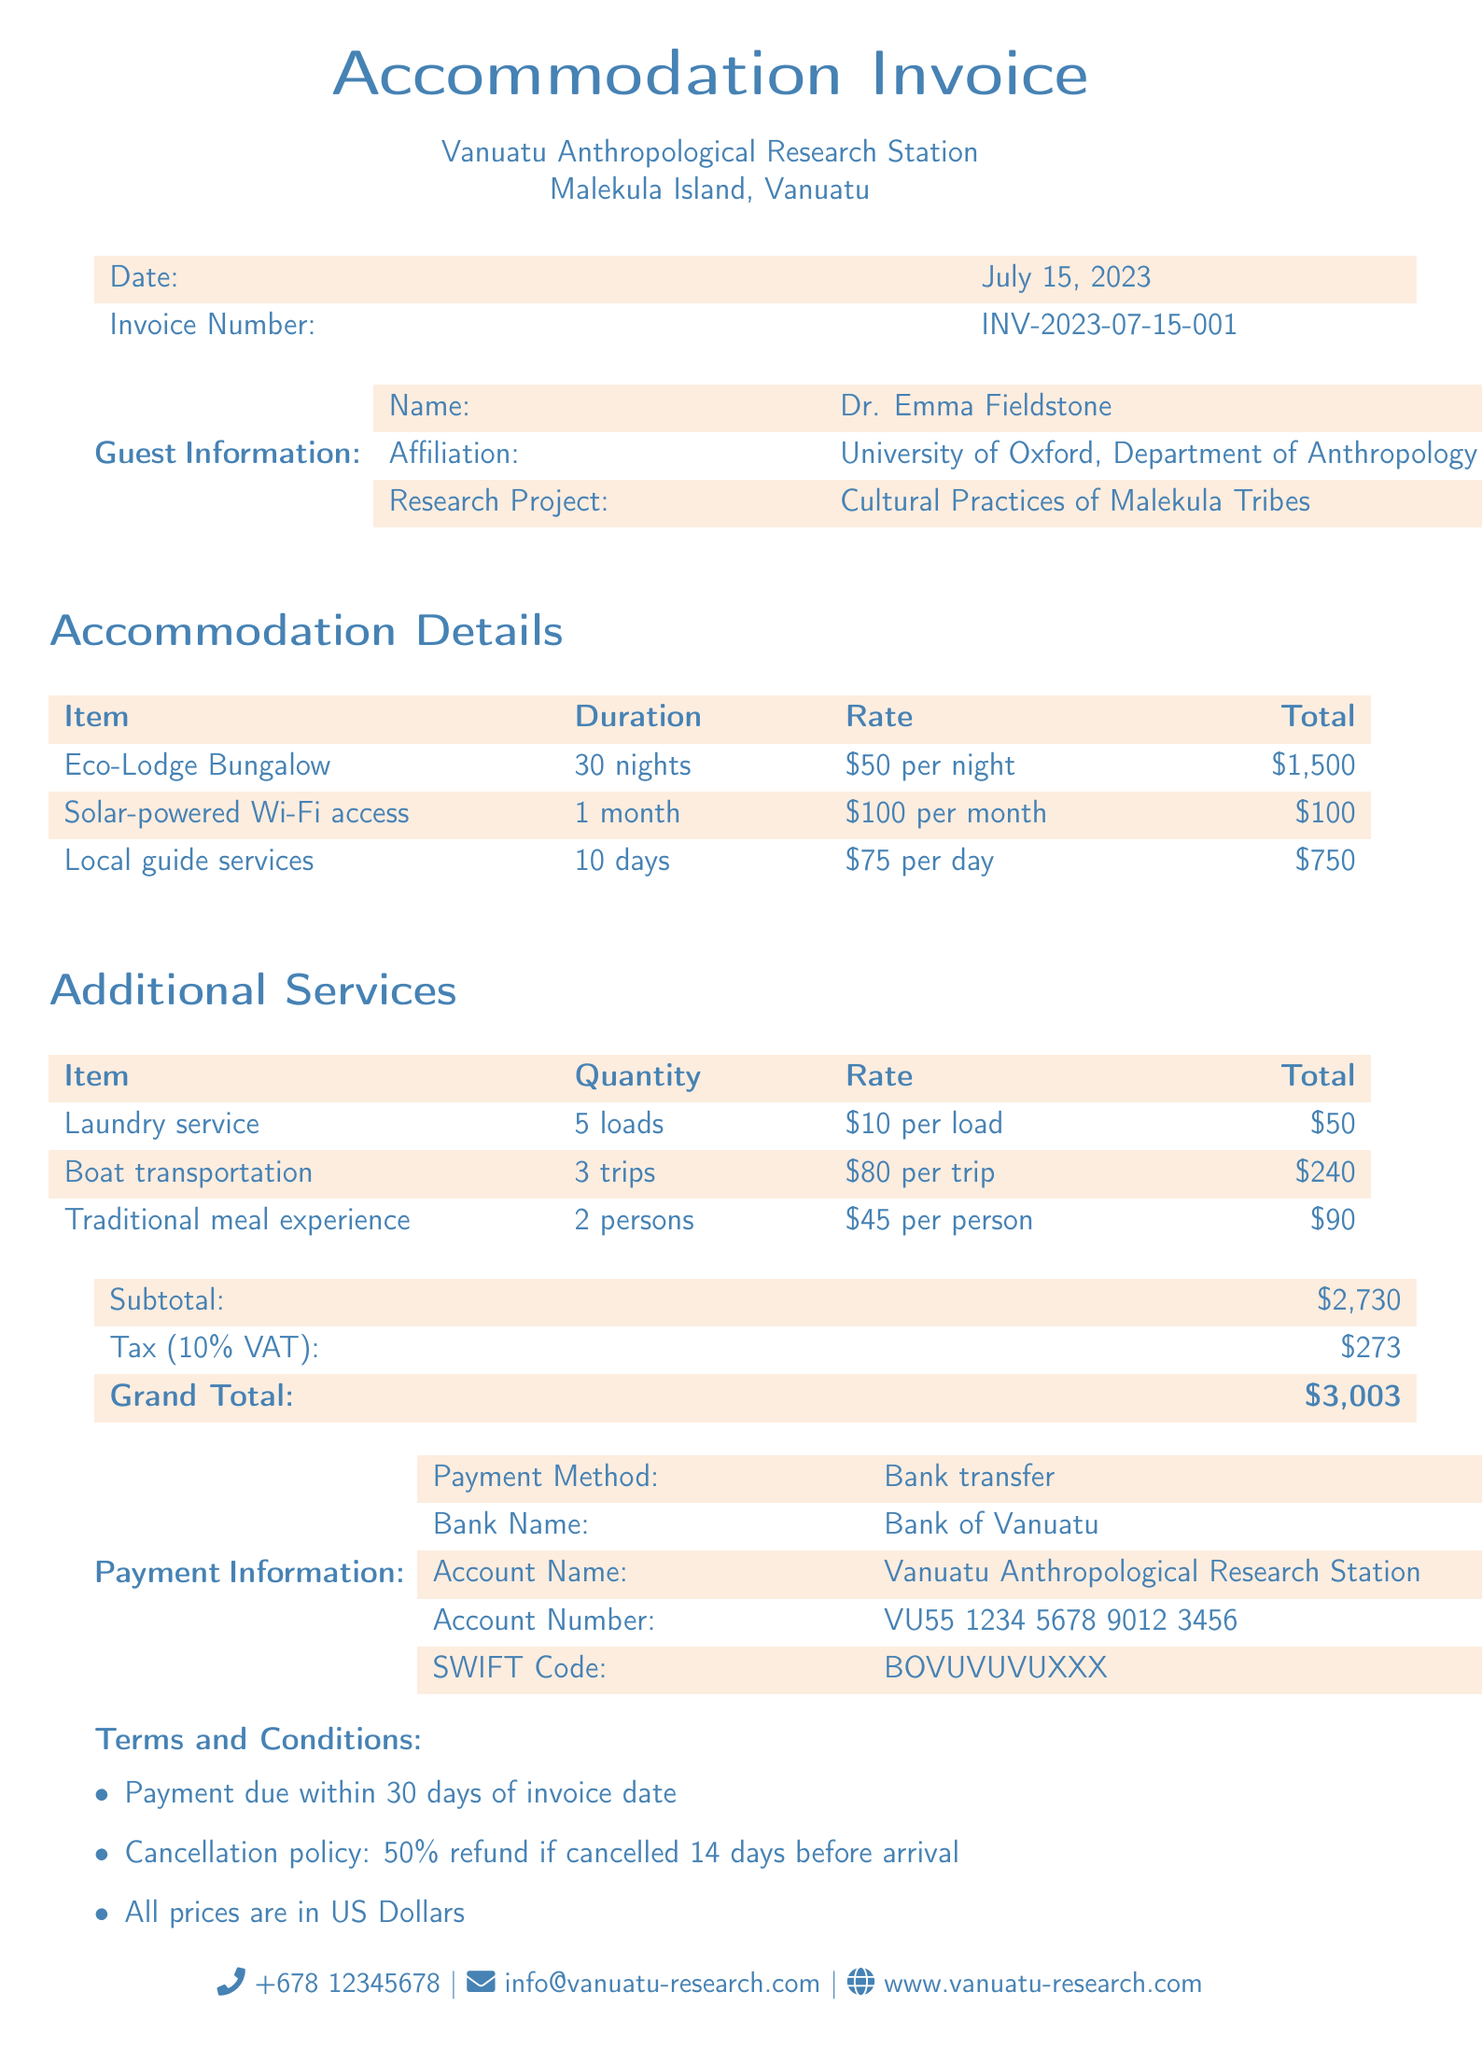what is the invoice number? The invoice number is a unique identifier for the bill, listed in the document.
Answer: INV-2023-07-15-001 who is the guest? The guest's name is provided in the document under guest information.
Answer: Dr. Emma Fieldstone what is the duration of the accommodation? The duration is mentioned for the Eco-Lodge Bungalow in the accommodation details.
Answer: 30 nights how much is the subtotal? The subtotal is the sum of all the charges listed before tax in the document.
Answer: $2,730 what is the VAT percentage applied? The VAT percentage is specified in the document, affecting the total amount due.
Answer: 10% how much is charged for local guide services? The total for local guide services is calculated based on the given rate and duration in the accommodation details.
Answer: $750 what payment method is specified? The document specifies how the payment should be made.
Answer: Bank transfer what is the cancellation policy? The policy stipulates what happens if a booking is canceled within a certain timeframe.
Answer: 50% refund if cancelled 14 days before arrival how many loads of laundry were serviced? The total quantity of laundry serviced is specified in the additional services section.
Answer: 5 loads 